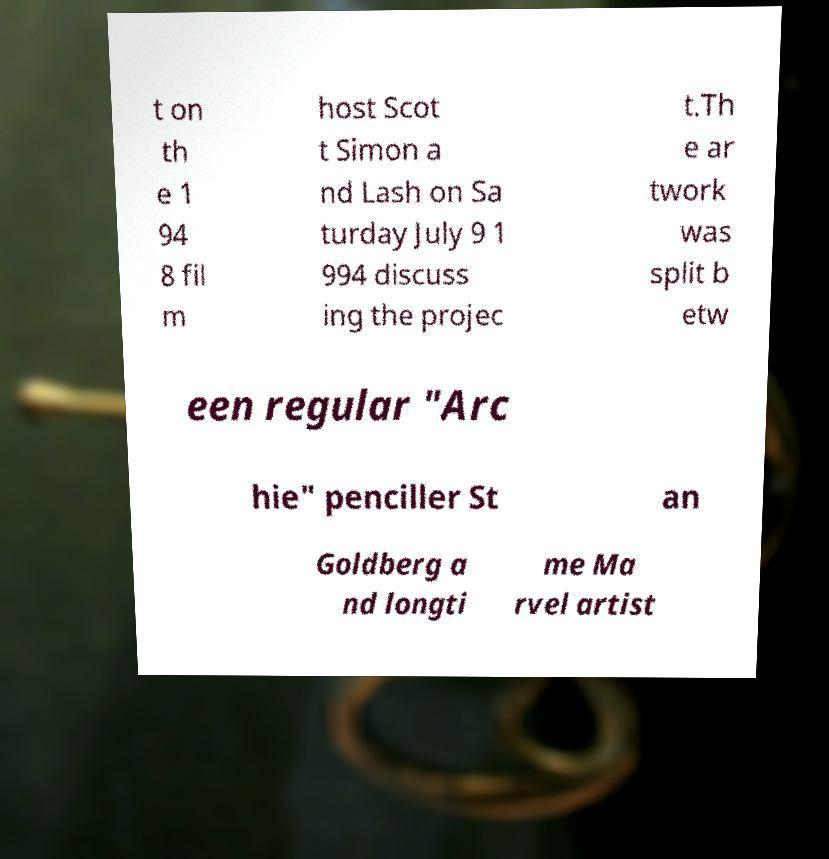What messages or text are displayed in this image? I need them in a readable, typed format. t on th e 1 94 8 fil m host Scot t Simon a nd Lash on Sa turday July 9 1 994 discuss ing the projec t.Th e ar twork was split b etw een regular "Arc hie" penciller St an Goldberg a nd longti me Ma rvel artist 